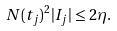<formula> <loc_0><loc_0><loc_500><loc_500>N ( t _ { j } ) ^ { 2 } | I _ { j } | \leq 2 \eta .</formula> 